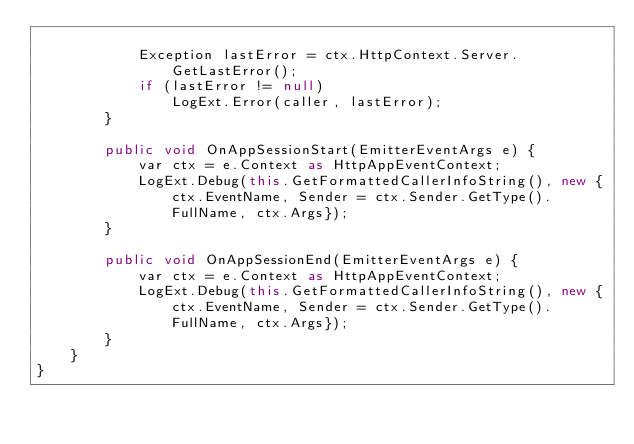<code> <loc_0><loc_0><loc_500><loc_500><_C#_>            
            Exception lastError = ctx.HttpContext.Server.GetLastError();
            if (lastError != null)
                LogExt.Error(caller, lastError);
        }

        public void OnAppSessionStart(EmitterEventArgs e) {
            var ctx = e.Context as HttpAppEventContext;
            LogExt.Debug(this.GetFormattedCallerInfoString(), new {ctx.EventName, Sender = ctx.Sender.GetType().FullName, ctx.Args});
        }

        public void OnAppSessionEnd(EmitterEventArgs e) {
            var ctx = e.Context as HttpAppEventContext;
            LogExt.Debug(this.GetFormattedCallerInfoString(), new {ctx.EventName, Sender = ctx.Sender.GetType().FullName, ctx.Args});
        }
    }
}</code> 